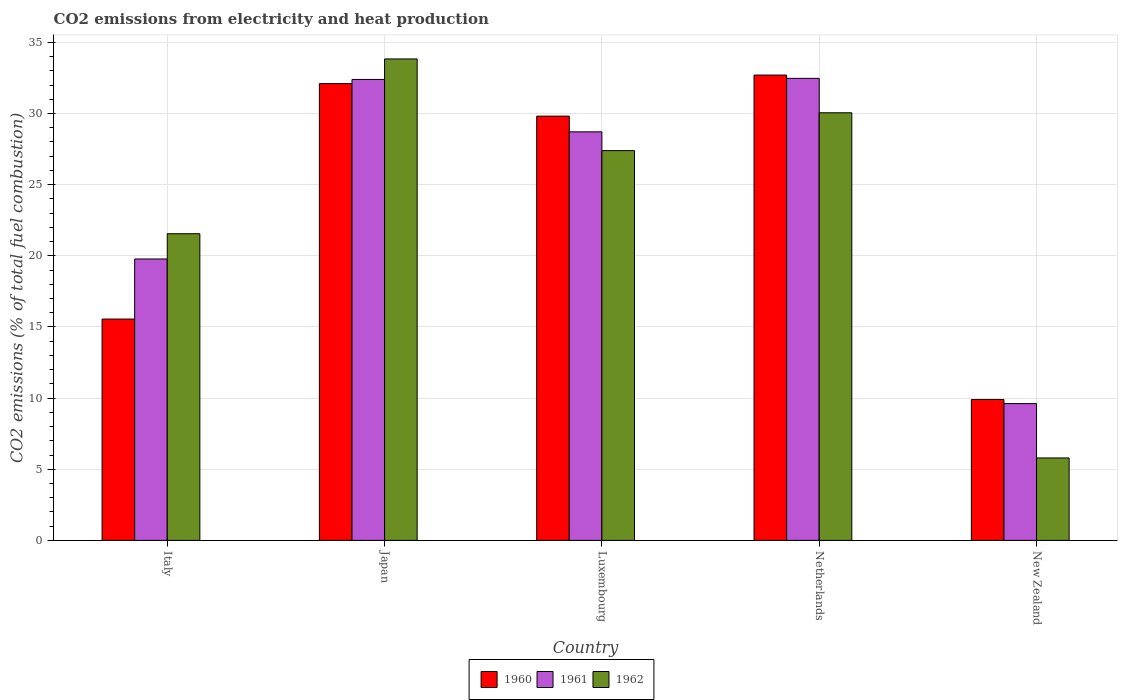How many different coloured bars are there?
Your response must be concise. 3. Are the number of bars on each tick of the X-axis equal?
Your response must be concise. Yes. How many bars are there on the 4th tick from the right?
Your answer should be very brief. 3. In how many cases, is the number of bars for a given country not equal to the number of legend labels?
Your answer should be compact. 0. What is the amount of CO2 emitted in 1960 in New Zealand?
Make the answer very short. 9.9. Across all countries, what is the maximum amount of CO2 emitted in 1960?
Ensure brevity in your answer.  32.7. Across all countries, what is the minimum amount of CO2 emitted in 1960?
Provide a short and direct response. 9.9. In which country was the amount of CO2 emitted in 1961 minimum?
Give a very brief answer. New Zealand. What is the total amount of CO2 emitted in 1961 in the graph?
Give a very brief answer. 122.96. What is the difference between the amount of CO2 emitted in 1960 in Italy and that in Netherlands?
Provide a succinct answer. -17.15. What is the difference between the amount of CO2 emitted in 1961 in Netherlands and the amount of CO2 emitted in 1962 in New Zealand?
Your response must be concise. 26.68. What is the average amount of CO2 emitted in 1961 per country?
Offer a very short reply. 24.59. What is the difference between the amount of CO2 emitted of/in 1960 and amount of CO2 emitted of/in 1962 in Netherlands?
Make the answer very short. 2.65. In how many countries, is the amount of CO2 emitted in 1962 greater than 15 %?
Keep it short and to the point. 4. What is the ratio of the amount of CO2 emitted in 1962 in Luxembourg to that in New Zealand?
Your response must be concise. 4.73. Is the difference between the amount of CO2 emitted in 1960 in Netherlands and New Zealand greater than the difference between the amount of CO2 emitted in 1962 in Netherlands and New Zealand?
Make the answer very short. No. What is the difference between the highest and the second highest amount of CO2 emitted in 1961?
Provide a succinct answer. 0.08. What is the difference between the highest and the lowest amount of CO2 emitted in 1960?
Ensure brevity in your answer.  22.8. In how many countries, is the amount of CO2 emitted in 1961 greater than the average amount of CO2 emitted in 1961 taken over all countries?
Your response must be concise. 3. Is the sum of the amount of CO2 emitted in 1960 in Netherlands and New Zealand greater than the maximum amount of CO2 emitted in 1962 across all countries?
Offer a very short reply. Yes. What does the 3rd bar from the left in Luxembourg represents?
Your answer should be very brief. 1962. What does the 2nd bar from the right in Japan represents?
Your response must be concise. 1961. Are all the bars in the graph horizontal?
Ensure brevity in your answer.  No. How many countries are there in the graph?
Your answer should be very brief. 5. What is the difference between two consecutive major ticks on the Y-axis?
Keep it short and to the point. 5. Are the values on the major ticks of Y-axis written in scientific E-notation?
Your response must be concise. No. Where does the legend appear in the graph?
Give a very brief answer. Bottom center. How many legend labels are there?
Your response must be concise. 3. How are the legend labels stacked?
Provide a succinct answer. Horizontal. What is the title of the graph?
Your answer should be compact. CO2 emissions from electricity and heat production. Does "2014" appear as one of the legend labels in the graph?
Offer a terse response. No. What is the label or title of the X-axis?
Provide a short and direct response. Country. What is the label or title of the Y-axis?
Your answer should be very brief. CO2 emissions (% of total fuel combustion). What is the CO2 emissions (% of total fuel combustion) in 1960 in Italy?
Your response must be concise. 15.55. What is the CO2 emissions (% of total fuel combustion) of 1961 in Italy?
Your response must be concise. 19.78. What is the CO2 emissions (% of total fuel combustion) in 1962 in Italy?
Provide a succinct answer. 21.55. What is the CO2 emissions (% of total fuel combustion) in 1960 in Japan?
Make the answer very short. 32.1. What is the CO2 emissions (% of total fuel combustion) in 1961 in Japan?
Your answer should be very brief. 32.39. What is the CO2 emissions (% of total fuel combustion) of 1962 in Japan?
Ensure brevity in your answer.  33.83. What is the CO2 emissions (% of total fuel combustion) in 1960 in Luxembourg?
Offer a terse response. 29.81. What is the CO2 emissions (% of total fuel combustion) in 1961 in Luxembourg?
Your answer should be compact. 28.71. What is the CO2 emissions (% of total fuel combustion) in 1962 in Luxembourg?
Offer a very short reply. 27.39. What is the CO2 emissions (% of total fuel combustion) of 1960 in Netherlands?
Make the answer very short. 32.7. What is the CO2 emissions (% of total fuel combustion) of 1961 in Netherlands?
Make the answer very short. 32.47. What is the CO2 emissions (% of total fuel combustion) in 1962 in Netherlands?
Offer a terse response. 30.05. What is the CO2 emissions (% of total fuel combustion) in 1960 in New Zealand?
Keep it short and to the point. 9.9. What is the CO2 emissions (% of total fuel combustion) in 1961 in New Zealand?
Offer a terse response. 9.61. What is the CO2 emissions (% of total fuel combustion) of 1962 in New Zealand?
Offer a very short reply. 5.79. Across all countries, what is the maximum CO2 emissions (% of total fuel combustion) in 1960?
Your answer should be compact. 32.7. Across all countries, what is the maximum CO2 emissions (% of total fuel combustion) of 1961?
Ensure brevity in your answer.  32.47. Across all countries, what is the maximum CO2 emissions (% of total fuel combustion) of 1962?
Give a very brief answer. 33.83. Across all countries, what is the minimum CO2 emissions (% of total fuel combustion) of 1960?
Your response must be concise. 9.9. Across all countries, what is the minimum CO2 emissions (% of total fuel combustion) of 1961?
Your answer should be very brief. 9.61. Across all countries, what is the minimum CO2 emissions (% of total fuel combustion) of 1962?
Give a very brief answer. 5.79. What is the total CO2 emissions (% of total fuel combustion) of 1960 in the graph?
Ensure brevity in your answer.  120.07. What is the total CO2 emissions (% of total fuel combustion) of 1961 in the graph?
Ensure brevity in your answer.  122.96. What is the total CO2 emissions (% of total fuel combustion) of 1962 in the graph?
Provide a succinct answer. 118.62. What is the difference between the CO2 emissions (% of total fuel combustion) in 1960 in Italy and that in Japan?
Provide a short and direct response. -16.55. What is the difference between the CO2 emissions (% of total fuel combustion) in 1961 in Italy and that in Japan?
Ensure brevity in your answer.  -12.62. What is the difference between the CO2 emissions (% of total fuel combustion) in 1962 in Italy and that in Japan?
Offer a terse response. -12.28. What is the difference between the CO2 emissions (% of total fuel combustion) in 1960 in Italy and that in Luxembourg?
Your answer should be compact. -14.26. What is the difference between the CO2 emissions (% of total fuel combustion) in 1961 in Italy and that in Luxembourg?
Provide a short and direct response. -8.93. What is the difference between the CO2 emissions (% of total fuel combustion) in 1962 in Italy and that in Luxembourg?
Give a very brief answer. -5.84. What is the difference between the CO2 emissions (% of total fuel combustion) of 1960 in Italy and that in Netherlands?
Keep it short and to the point. -17.15. What is the difference between the CO2 emissions (% of total fuel combustion) of 1961 in Italy and that in Netherlands?
Offer a terse response. -12.69. What is the difference between the CO2 emissions (% of total fuel combustion) of 1962 in Italy and that in Netherlands?
Ensure brevity in your answer.  -8.5. What is the difference between the CO2 emissions (% of total fuel combustion) of 1960 in Italy and that in New Zealand?
Offer a very short reply. 5.65. What is the difference between the CO2 emissions (% of total fuel combustion) of 1961 in Italy and that in New Zealand?
Offer a terse response. 10.16. What is the difference between the CO2 emissions (% of total fuel combustion) in 1962 in Italy and that in New Zealand?
Offer a very short reply. 15.76. What is the difference between the CO2 emissions (% of total fuel combustion) of 1960 in Japan and that in Luxembourg?
Provide a succinct answer. 2.29. What is the difference between the CO2 emissions (% of total fuel combustion) in 1961 in Japan and that in Luxembourg?
Your response must be concise. 3.68. What is the difference between the CO2 emissions (% of total fuel combustion) of 1962 in Japan and that in Luxembourg?
Make the answer very short. 6.44. What is the difference between the CO2 emissions (% of total fuel combustion) in 1960 in Japan and that in Netherlands?
Ensure brevity in your answer.  -0.6. What is the difference between the CO2 emissions (% of total fuel combustion) in 1961 in Japan and that in Netherlands?
Keep it short and to the point. -0.08. What is the difference between the CO2 emissions (% of total fuel combustion) in 1962 in Japan and that in Netherlands?
Provide a succinct answer. 3.78. What is the difference between the CO2 emissions (% of total fuel combustion) of 1960 in Japan and that in New Zealand?
Your answer should be compact. 22.2. What is the difference between the CO2 emissions (% of total fuel combustion) of 1961 in Japan and that in New Zealand?
Provide a succinct answer. 22.78. What is the difference between the CO2 emissions (% of total fuel combustion) of 1962 in Japan and that in New Zealand?
Your answer should be compact. 28.04. What is the difference between the CO2 emissions (% of total fuel combustion) in 1960 in Luxembourg and that in Netherlands?
Offer a terse response. -2.89. What is the difference between the CO2 emissions (% of total fuel combustion) of 1961 in Luxembourg and that in Netherlands?
Provide a succinct answer. -3.76. What is the difference between the CO2 emissions (% of total fuel combustion) in 1962 in Luxembourg and that in Netherlands?
Your answer should be very brief. -2.66. What is the difference between the CO2 emissions (% of total fuel combustion) of 1960 in Luxembourg and that in New Zealand?
Your response must be concise. 19.91. What is the difference between the CO2 emissions (% of total fuel combustion) in 1961 in Luxembourg and that in New Zealand?
Give a very brief answer. 19.1. What is the difference between the CO2 emissions (% of total fuel combustion) of 1962 in Luxembourg and that in New Zealand?
Give a very brief answer. 21.6. What is the difference between the CO2 emissions (% of total fuel combustion) in 1960 in Netherlands and that in New Zealand?
Give a very brief answer. 22.8. What is the difference between the CO2 emissions (% of total fuel combustion) of 1961 in Netherlands and that in New Zealand?
Ensure brevity in your answer.  22.86. What is the difference between the CO2 emissions (% of total fuel combustion) in 1962 in Netherlands and that in New Zealand?
Offer a very short reply. 24.26. What is the difference between the CO2 emissions (% of total fuel combustion) of 1960 in Italy and the CO2 emissions (% of total fuel combustion) of 1961 in Japan?
Your answer should be compact. -16.84. What is the difference between the CO2 emissions (% of total fuel combustion) in 1960 in Italy and the CO2 emissions (% of total fuel combustion) in 1962 in Japan?
Your answer should be compact. -18.28. What is the difference between the CO2 emissions (% of total fuel combustion) of 1961 in Italy and the CO2 emissions (% of total fuel combustion) of 1962 in Japan?
Make the answer very short. -14.06. What is the difference between the CO2 emissions (% of total fuel combustion) of 1960 in Italy and the CO2 emissions (% of total fuel combustion) of 1961 in Luxembourg?
Give a very brief answer. -13.16. What is the difference between the CO2 emissions (% of total fuel combustion) in 1960 in Italy and the CO2 emissions (% of total fuel combustion) in 1962 in Luxembourg?
Your answer should be very brief. -11.84. What is the difference between the CO2 emissions (% of total fuel combustion) of 1961 in Italy and the CO2 emissions (% of total fuel combustion) of 1962 in Luxembourg?
Make the answer very short. -7.62. What is the difference between the CO2 emissions (% of total fuel combustion) in 1960 in Italy and the CO2 emissions (% of total fuel combustion) in 1961 in Netherlands?
Keep it short and to the point. -16.92. What is the difference between the CO2 emissions (% of total fuel combustion) in 1960 in Italy and the CO2 emissions (% of total fuel combustion) in 1962 in Netherlands?
Provide a succinct answer. -14.5. What is the difference between the CO2 emissions (% of total fuel combustion) of 1961 in Italy and the CO2 emissions (% of total fuel combustion) of 1962 in Netherlands?
Offer a very short reply. -10.27. What is the difference between the CO2 emissions (% of total fuel combustion) in 1960 in Italy and the CO2 emissions (% of total fuel combustion) in 1961 in New Zealand?
Provide a short and direct response. 5.94. What is the difference between the CO2 emissions (% of total fuel combustion) in 1960 in Italy and the CO2 emissions (% of total fuel combustion) in 1962 in New Zealand?
Offer a very short reply. 9.76. What is the difference between the CO2 emissions (% of total fuel combustion) in 1961 in Italy and the CO2 emissions (% of total fuel combustion) in 1962 in New Zealand?
Make the answer very short. 13.98. What is the difference between the CO2 emissions (% of total fuel combustion) of 1960 in Japan and the CO2 emissions (% of total fuel combustion) of 1961 in Luxembourg?
Provide a short and direct response. 3.39. What is the difference between the CO2 emissions (% of total fuel combustion) in 1960 in Japan and the CO2 emissions (% of total fuel combustion) in 1962 in Luxembourg?
Make the answer very short. 4.71. What is the difference between the CO2 emissions (% of total fuel combustion) of 1961 in Japan and the CO2 emissions (% of total fuel combustion) of 1962 in Luxembourg?
Keep it short and to the point. 5. What is the difference between the CO2 emissions (% of total fuel combustion) of 1960 in Japan and the CO2 emissions (% of total fuel combustion) of 1961 in Netherlands?
Ensure brevity in your answer.  -0.37. What is the difference between the CO2 emissions (% of total fuel combustion) in 1960 in Japan and the CO2 emissions (% of total fuel combustion) in 1962 in Netherlands?
Offer a terse response. 2.05. What is the difference between the CO2 emissions (% of total fuel combustion) of 1961 in Japan and the CO2 emissions (% of total fuel combustion) of 1962 in Netherlands?
Offer a very short reply. 2.34. What is the difference between the CO2 emissions (% of total fuel combustion) of 1960 in Japan and the CO2 emissions (% of total fuel combustion) of 1961 in New Zealand?
Your response must be concise. 22.49. What is the difference between the CO2 emissions (% of total fuel combustion) of 1960 in Japan and the CO2 emissions (% of total fuel combustion) of 1962 in New Zealand?
Offer a very short reply. 26.31. What is the difference between the CO2 emissions (% of total fuel combustion) in 1961 in Japan and the CO2 emissions (% of total fuel combustion) in 1962 in New Zealand?
Your answer should be compact. 26.6. What is the difference between the CO2 emissions (% of total fuel combustion) in 1960 in Luxembourg and the CO2 emissions (% of total fuel combustion) in 1961 in Netherlands?
Keep it short and to the point. -2.66. What is the difference between the CO2 emissions (% of total fuel combustion) in 1960 in Luxembourg and the CO2 emissions (% of total fuel combustion) in 1962 in Netherlands?
Ensure brevity in your answer.  -0.24. What is the difference between the CO2 emissions (% of total fuel combustion) of 1961 in Luxembourg and the CO2 emissions (% of total fuel combustion) of 1962 in Netherlands?
Your answer should be very brief. -1.34. What is the difference between the CO2 emissions (% of total fuel combustion) of 1960 in Luxembourg and the CO2 emissions (% of total fuel combustion) of 1961 in New Zealand?
Provide a short and direct response. 20.2. What is the difference between the CO2 emissions (% of total fuel combustion) of 1960 in Luxembourg and the CO2 emissions (% of total fuel combustion) of 1962 in New Zealand?
Ensure brevity in your answer.  24.02. What is the difference between the CO2 emissions (% of total fuel combustion) of 1961 in Luxembourg and the CO2 emissions (% of total fuel combustion) of 1962 in New Zealand?
Your answer should be very brief. 22.92. What is the difference between the CO2 emissions (% of total fuel combustion) in 1960 in Netherlands and the CO2 emissions (% of total fuel combustion) in 1961 in New Zealand?
Offer a very short reply. 23.09. What is the difference between the CO2 emissions (% of total fuel combustion) in 1960 in Netherlands and the CO2 emissions (% of total fuel combustion) in 1962 in New Zealand?
Make the answer very short. 26.91. What is the difference between the CO2 emissions (% of total fuel combustion) in 1961 in Netherlands and the CO2 emissions (% of total fuel combustion) in 1962 in New Zealand?
Offer a very short reply. 26.68. What is the average CO2 emissions (% of total fuel combustion) of 1960 per country?
Offer a terse response. 24.01. What is the average CO2 emissions (% of total fuel combustion) in 1961 per country?
Your answer should be compact. 24.59. What is the average CO2 emissions (% of total fuel combustion) of 1962 per country?
Your answer should be compact. 23.72. What is the difference between the CO2 emissions (% of total fuel combustion) of 1960 and CO2 emissions (% of total fuel combustion) of 1961 in Italy?
Your answer should be compact. -4.22. What is the difference between the CO2 emissions (% of total fuel combustion) of 1960 and CO2 emissions (% of total fuel combustion) of 1962 in Italy?
Your response must be concise. -6. What is the difference between the CO2 emissions (% of total fuel combustion) of 1961 and CO2 emissions (% of total fuel combustion) of 1962 in Italy?
Your answer should be compact. -1.78. What is the difference between the CO2 emissions (% of total fuel combustion) of 1960 and CO2 emissions (% of total fuel combustion) of 1961 in Japan?
Keep it short and to the point. -0.29. What is the difference between the CO2 emissions (% of total fuel combustion) in 1960 and CO2 emissions (% of total fuel combustion) in 1962 in Japan?
Provide a short and direct response. -1.73. What is the difference between the CO2 emissions (% of total fuel combustion) of 1961 and CO2 emissions (% of total fuel combustion) of 1962 in Japan?
Offer a very short reply. -1.44. What is the difference between the CO2 emissions (% of total fuel combustion) of 1960 and CO2 emissions (% of total fuel combustion) of 1961 in Luxembourg?
Ensure brevity in your answer.  1.1. What is the difference between the CO2 emissions (% of total fuel combustion) in 1960 and CO2 emissions (% of total fuel combustion) in 1962 in Luxembourg?
Ensure brevity in your answer.  2.42. What is the difference between the CO2 emissions (% of total fuel combustion) of 1961 and CO2 emissions (% of total fuel combustion) of 1962 in Luxembourg?
Make the answer very short. 1.32. What is the difference between the CO2 emissions (% of total fuel combustion) in 1960 and CO2 emissions (% of total fuel combustion) in 1961 in Netherlands?
Provide a short and direct response. 0.23. What is the difference between the CO2 emissions (% of total fuel combustion) in 1960 and CO2 emissions (% of total fuel combustion) in 1962 in Netherlands?
Offer a terse response. 2.65. What is the difference between the CO2 emissions (% of total fuel combustion) of 1961 and CO2 emissions (% of total fuel combustion) of 1962 in Netherlands?
Give a very brief answer. 2.42. What is the difference between the CO2 emissions (% of total fuel combustion) in 1960 and CO2 emissions (% of total fuel combustion) in 1961 in New Zealand?
Your answer should be compact. 0.29. What is the difference between the CO2 emissions (% of total fuel combustion) of 1960 and CO2 emissions (% of total fuel combustion) of 1962 in New Zealand?
Make the answer very short. 4.11. What is the difference between the CO2 emissions (% of total fuel combustion) of 1961 and CO2 emissions (% of total fuel combustion) of 1962 in New Zealand?
Keep it short and to the point. 3.82. What is the ratio of the CO2 emissions (% of total fuel combustion) of 1960 in Italy to that in Japan?
Your answer should be very brief. 0.48. What is the ratio of the CO2 emissions (% of total fuel combustion) in 1961 in Italy to that in Japan?
Your answer should be very brief. 0.61. What is the ratio of the CO2 emissions (% of total fuel combustion) in 1962 in Italy to that in Japan?
Make the answer very short. 0.64. What is the ratio of the CO2 emissions (% of total fuel combustion) of 1960 in Italy to that in Luxembourg?
Your answer should be very brief. 0.52. What is the ratio of the CO2 emissions (% of total fuel combustion) of 1961 in Italy to that in Luxembourg?
Offer a terse response. 0.69. What is the ratio of the CO2 emissions (% of total fuel combustion) in 1962 in Italy to that in Luxembourg?
Your answer should be very brief. 0.79. What is the ratio of the CO2 emissions (% of total fuel combustion) of 1960 in Italy to that in Netherlands?
Make the answer very short. 0.48. What is the ratio of the CO2 emissions (% of total fuel combustion) of 1961 in Italy to that in Netherlands?
Offer a terse response. 0.61. What is the ratio of the CO2 emissions (% of total fuel combustion) of 1962 in Italy to that in Netherlands?
Offer a terse response. 0.72. What is the ratio of the CO2 emissions (% of total fuel combustion) in 1960 in Italy to that in New Zealand?
Offer a terse response. 1.57. What is the ratio of the CO2 emissions (% of total fuel combustion) in 1961 in Italy to that in New Zealand?
Give a very brief answer. 2.06. What is the ratio of the CO2 emissions (% of total fuel combustion) in 1962 in Italy to that in New Zealand?
Offer a terse response. 3.72. What is the ratio of the CO2 emissions (% of total fuel combustion) in 1960 in Japan to that in Luxembourg?
Offer a very short reply. 1.08. What is the ratio of the CO2 emissions (% of total fuel combustion) in 1961 in Japan to that in Luxembourg?
Keep it short and to the point. 1.13. What is the ratio of the CO2 emissions (% of total fuel combustion) of 1962 in Japan to that in Luxembourg?
Your answer should be very brief. 1.24. What is the ratio of the CO2 emissions (% of total fuel combustion) of 1960 in Japan to that in Netherlands?
Offer a very short reply. 0.98. What is the ratio of the CO2 emissions (% of total fuel combustion) in 1961 in Japan to that in Netherlands?
Your answer should be compact. 1. What is the ratio of the CO2 emissions (% of total fuel combustion) of 1962 in Japan to that in Netherlands?
Offer a very short reply. 1.13. What is the ratio of the CO2 emissions (% of total fuel combustion) in 1960 in Japan to that in New Zealand?
Offer a terse response. 3.24. What is the ratio of the CO2 emissions (% of total fuel combustion) of 1961 in Japan to that in New Zealand?
Make the answer very short. 3.37. What is the ratio of the CO2 emissions (% of total fuel combustion) in 1962 in Japan to that in New Zealand?
Ensure brevity in your answer.  5.84. What is the ratio of the CO2 emissions (% of total fuel combustion) of 1960 in Luxembourg to that in Netherlands?
Offer a very short reply. 0.91. What is the ratio of the CO2 emissions (% of total fuel combustion) of 1961 in Luxembourg to that in Netherlands?
Keep it short and to the point. 0.88. What is the ratio of the CO2 emissions (% of total fuel combustion) in 1962 in Luxembourg to that in Netherlands?
Make the answer very short. 0.91. What is the ratio of the CO2 emissions (% of total fuel combustion) in 1960 in Luxembourg to that in New Zealand?
Make the answer very short. 3.01. What is the ratio of the CO2 emissions (% of total fuel combustion) of 1961 in Luxembourg to that in New Zealand?
Keep it short and to the point. 2.99. What is the ratio of the CO2 emissions (% of total fuel combustion) of 1962 in Luxembourg to that in New Zealand?
Provide a short and direct response. 4.73. What is the ratio of the CO2 emissions (% of total fuel combustion) of 1960 in Netherlands to that in New Zealand?
Your answer should be compact. 3.3. What is the ratio of the CO2 emissions (% of total fuel combustion) of 1961 in Netherlands to that in New Zealand?
Provide a short and direct response. 3.38. What is the ratio of the CO2 emissions (% of total fuel combustion) in 1962 in Netherlands to that in New Zealand?
Provide a short and direct response. 5.19. What is the difference between the highest and the second highest CO2 emissions (% of total fuel combustion) in 1960?
Your answer should be very brief. 0.6. What is the difference between the highest and the second highest CO2 emissions (% of total fuel combustion) in 1961?
Keep it short and to the point. 0.08. What is the difference between the highest and the second highest CO2 emissions (% of total fuel combustion) in 1962?
Keep it short and to the point. 3.78. What is the difference between the highest and the lowest CO2 emissions (% of total fuel combustion) of 1960?
Your answer should be compact. 22.8. What is the difference between the highest and the lowest CO2 emissions (% of total fuel combustion) in 1961?
Offer a terse response. 22.86. What is the difference between the highest and the lowest CO2 emissions (% of total fuel combustion) in 1962?
Offer a very short reply. 28.04. 